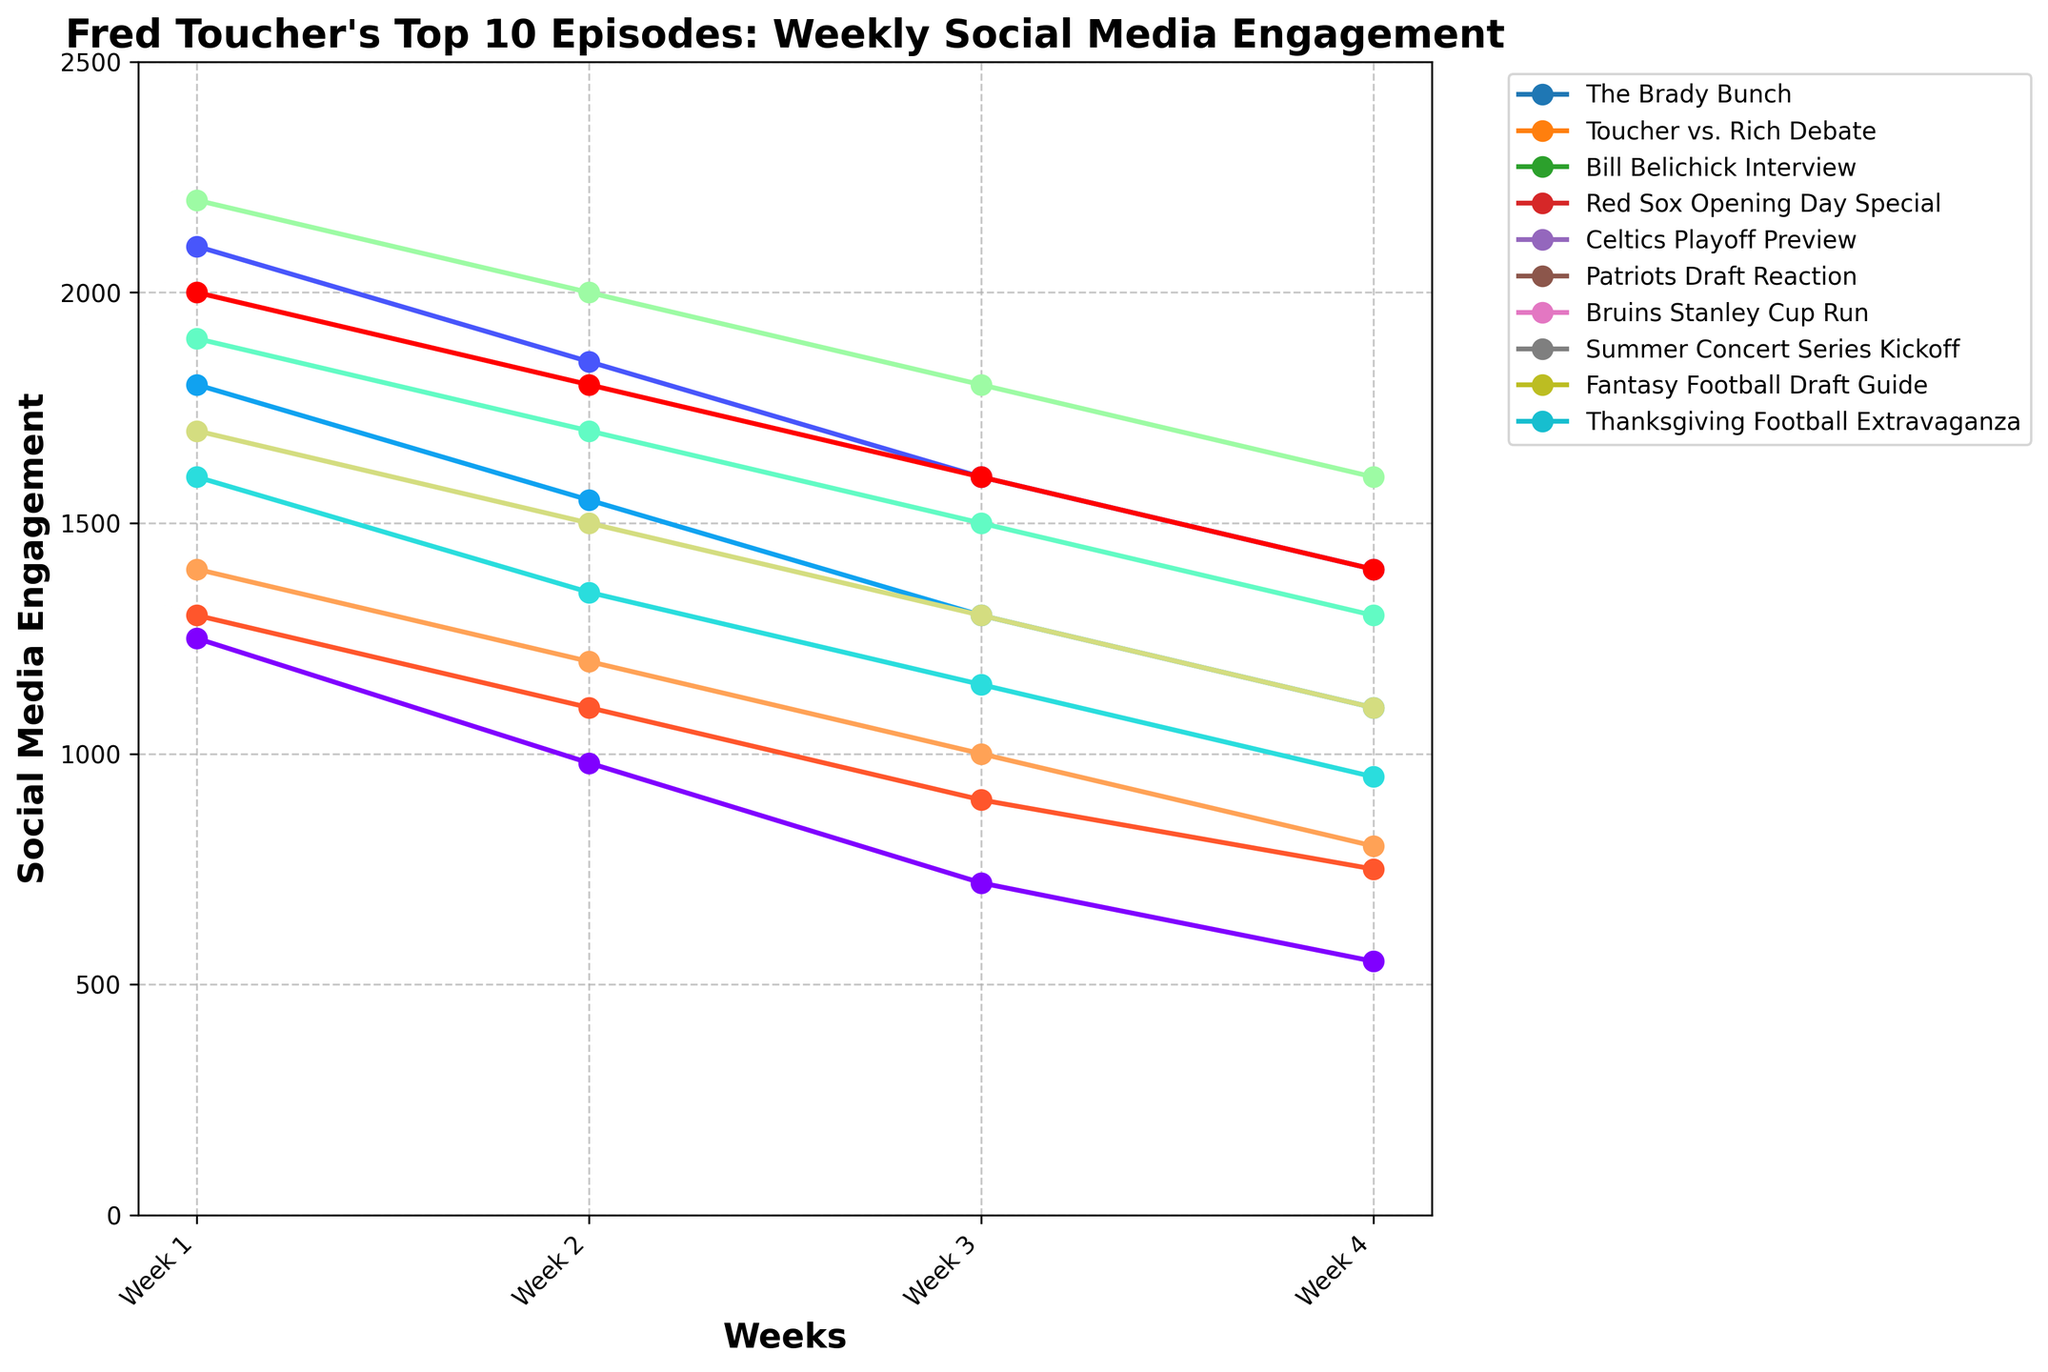Which episode has the highest initial engagement in Week 1? Look at the starting points of each line on the figure. The episode with the highest point in Week 1 is the "Patriots Draft Reaction".
Answer: "Patriots Draft Reaction" Which episode sees the steepest decline in engagement from Week 1 to Week 4? Calculate the difference in engagement from Week 1 to Week 4 for each episode and find the largest drop. The "Patriots Draft Reaction" goes from 2200 to 1600, a drop of 600, which is the largest.
Answer: "Patriots Draft Reaction" Which episodes have an engagement higher than 1500 in Week 2? Look at the values in Week 2 for each episode. The episodes "Toucher vs. Rich Debate", "Bill Belichick Interview", "Celtics Playoff Preview", "Patriots Draft Reaction", and "Thanksgiving Football Extravaganza" all have values above 1500.
Answer: "Toucher vs. Rich Debate", "Bill Belichick Interview", "Celtics Playoff Preview", "Patriots Draft Reaction", "Thanksgiving Football Extravaganza" Which episode has the most consistent engagement (the smallest difference between highest and lowest engagements) over the four weeks? Calculate the difference between the highest and lowest engagement for each episode. "Fantasy Football Draft Guide" ranges from 1300 to 750, a difference of 550, which is the smallest among all episodes.
Answer: "Fantasy Football Draft Guide" How does the engagement for "Bruins Stanley Cup Run" compare to "Red Sox Opening Day Special" in Week 3? Compare the points for Week 3 of both episodes. "Bruins Stanley Cup Run" has an engagement of 1300 and "Red Sox Opening Day Special" has an engagement of 1150.
Answer: "Bruins Stanley Cup Run" is higher What is the average engagement for "Bill Belichick Interview" over the four weeks? Sum the weekly engagement values for "Bill Belichick Interview" (1800, 1550, 1300, 1100) and divide by 4. The sum is 5750, and the average is 5750/4 = 1437.5.
Answer: 1437.5 Which episodes experienced a drop in engagement every week? Identify episodes where each consecutive week has lower engagement. "The Brady Bunch", "Toucher vs. Rich Debate", "Bill Belichick Interview", "Red Sox Opening Day Special", "Patriots Draft Reaction", "Summer Concert Series Kickoff", "Fantasy Football Draft Guide" meet this condition.
Answer: "The Brady Bunch", "Toucher vs. Rich Debate", "Bill Belichick Interview", "Red Sox Opening Day Special", "Patriots Draft Reaction", "Summer Concert Series Kickoff", "Fantasy Football Draft Guide" Which episode had the lowest engagement in Week 4? Look at the endpoints on the figure for Week 4. The lowest endpoint is for "Summer Concert Series Kickoff" with 800.
Answer: "Summer Concert Series Kickoff" What is the total engagement for "Celtics Playoff Preview" over the four weeks? Sum the engagement values for each week for "Celtics Playoff Preview" (1900, 1700, 1500, 1300). The total is 1900 + 1700 + 1500 + 1300 = 6400.
Answer: 6400 Which episode had higher engagement in Week 2: "The Brady Bunch" or "Fantasy Football Draft Guide"? Compare the values for Week 2 for both episodes. "The Brady Bunch" has 980, and "Fantasy Football Draft Guide" has 1100.
Answer: "Fantasy Football Draft Guide" 